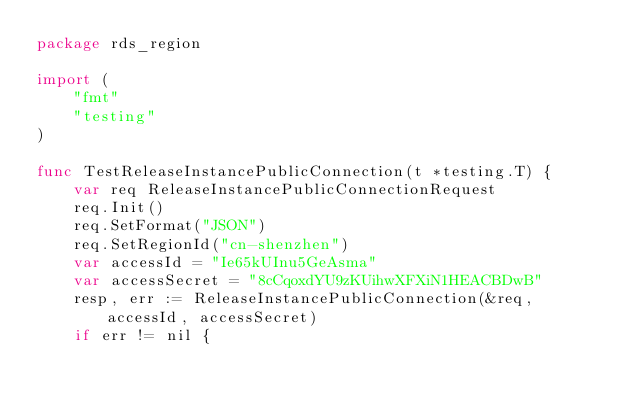Convert code to text. <code><loc_0><loc_0><loc_500><loc_500><_Go_>package rds_region

import (
	"fmt"
	"testing"
)

func TestReleaseInstancePublicConnection(t *testing.T) {
	var req ReleaseInstancePublicConnectionRequest
	req.Init()
	req.SetFormat("JSON")
	req.SetRegionId("cn-shenzhen")
	var accessId = "Ie65kUInu5GeAsma"
	var accessSecret = "8cCqoxdYU9zKUihwXFXiN1HEACBDwB"
	resp, err := ReleaseInstancePublicConnection(&req, accessId, accessSecret)
	if err != nil {</code> 